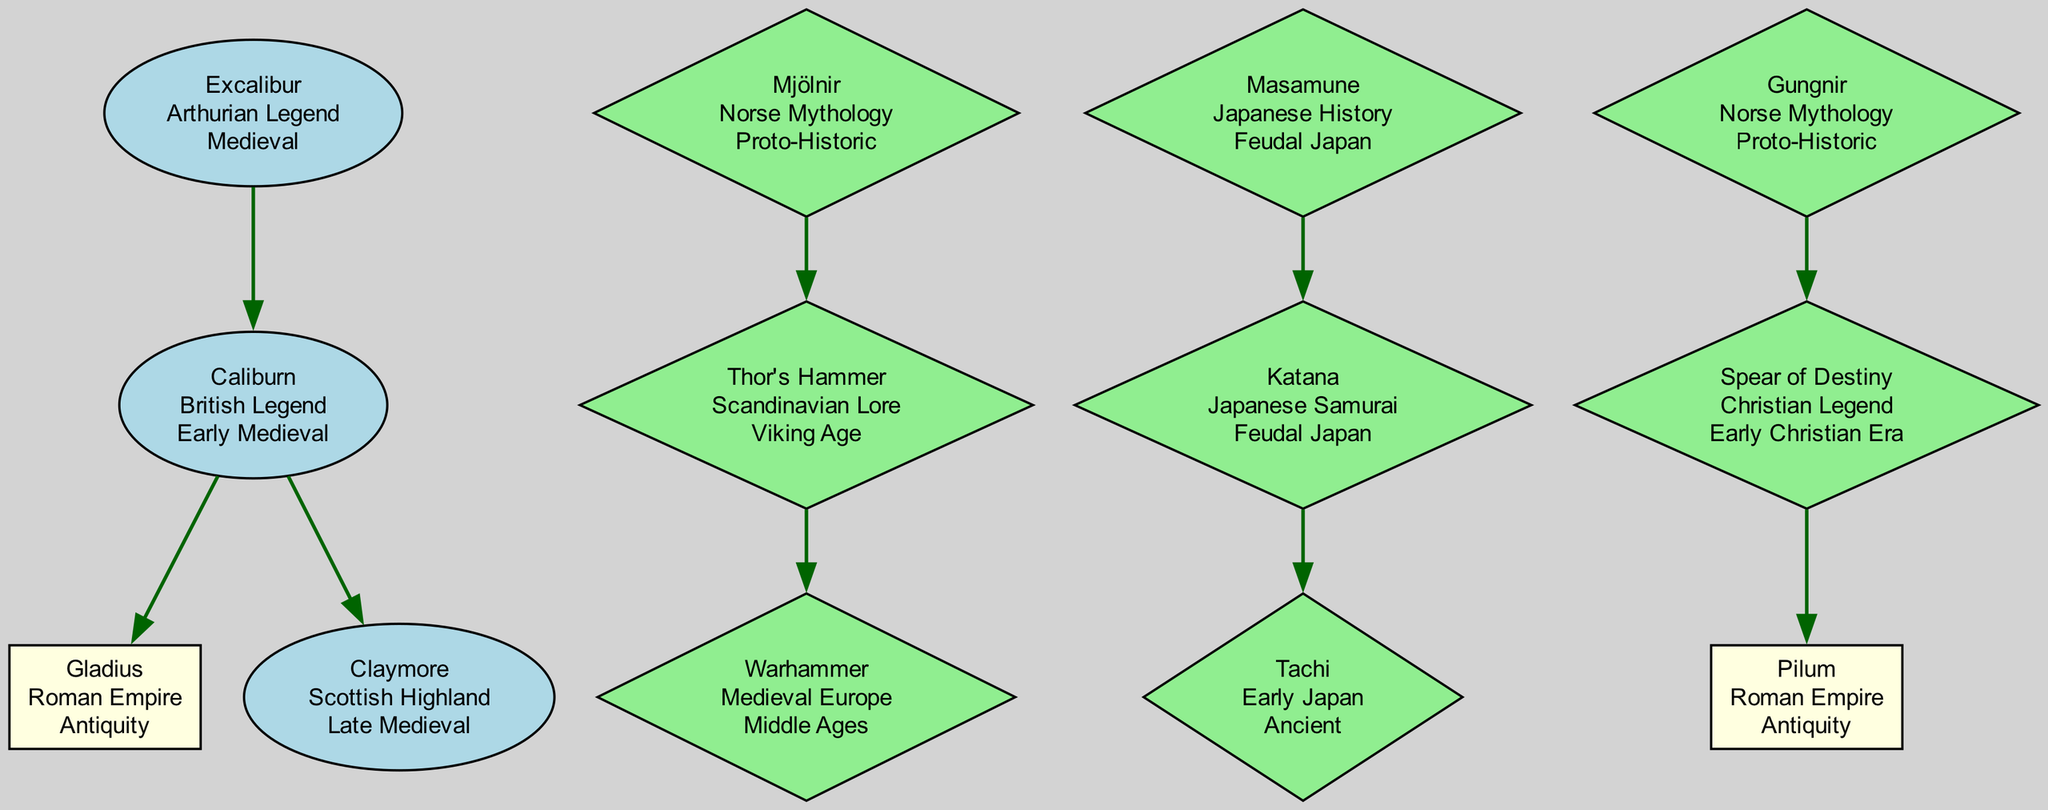What is the origin of Excalibur? The diagram shows that Excalibur has the origin listed as "Arthurian Legend." This information is directly displayed in the node for Excalibur.
Answer: Arthurian Legend How many subordinate weapons does Mjölnir have? The Mjölnir node in the diagram indicates it has one subordinate weapon, which is Thor's Hammer. By counting the subordinate weapons, it is clear there is only one.
Answer: 1 What is the age of the Claymore? The age of the Claymore is indicated in the diagram as "Late Medieval." This information is displayed in the node corresponding to the Claymore.
Answer: Late Medieval Which weapon has the origin "Japanese Samurai"? By examining the diagram, it is clear that the weapon with the origin "Japanese Samurai" is the Katana. This is indicated under the Masamune node where its subordinate weapon is listed.
Answer: Katana Which legendary weapon has the most subordinate weapons? By analyzing the connections in the diagram, Excalibur appears to have two subordinate weapons (Caliburn, and within that, Gladius and Claymore), which is more than other weapons. Thus, Excalibur has the highest count.
Answer: Excalibur What relationship does Masamune have with Tachi? In the diagram, Masamune is the parent node of Katana, which then has Tachi as its subordinate weapon. This indicates that Masamune is the ancestor of Tachi within the weapon lineage.
Answer: Parent What is the common origin of both Gungnir and Mjölnir? Looking at the diagram, both Gungnir and Mjölnir share the origin listed as "Norse Mythology," demonstrating a common cultural background for these legendary weapons.
Answer: Norse Mythology Which weapon is the earliest in historical context? By evaluating the ages of the weapons listed in the diagram, the weapon with the earliest historical context is Gladius, as it is labeled "Antiquity." Therefore, it is historically the oldest among the weapons.
Answer: Gladius How many legendary weapons are from Norse Mythology? The diagram shows two weapons related to Norse Mythology: Mjölnir and Gungnir. Counting these nodes reveals the total number of weapons from this origin.
Answer: 2 